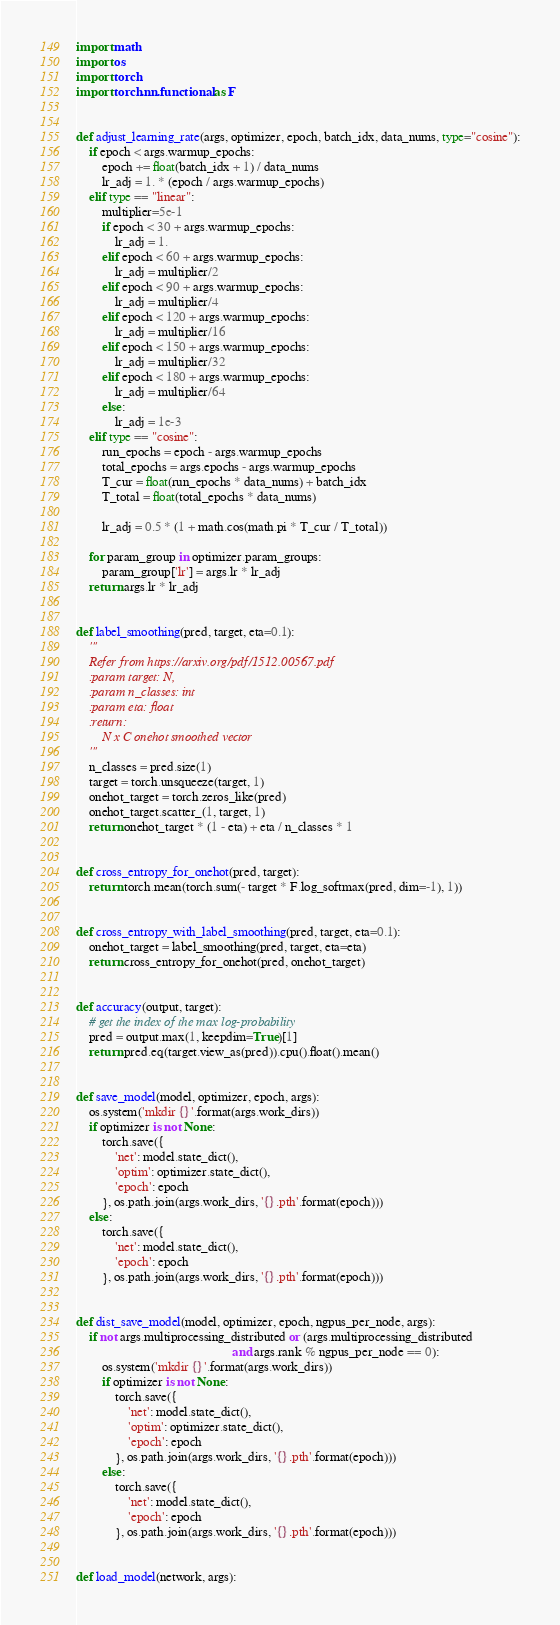Convert code to text. <code><loc_0><loc_0><loc_500><loc_500><_Python_>import math
import os
import torch
import torch.nn.functional as F


def adjust_learning_rate(args, optimizer, epoch, batch_idx, data_nums, type="cosine"):
    if epoch < args.warmup_epochs:
        epoch += float(batch_idx + 1) / data_nums
        lr_adj = 1. * (epoch / args.warmup_epochs)
    elif type == "linear":
        multiplier=5e-1
        if epoch < 30 + args.warmup_epochs:
            lr_adj = 1.
        elif epoch < 60 + args.warmup_epochs:
            lr_adj = multiplier/2
        elif epoch < 90 + args.warmup_epochs:
            lr_adj = multiplier/4
        elif epoch < 120 + args.warmup_epochs:
            lr_adj = multiplier/16
        elif epoch < 150 + args.warmup_epochs:
            lr_adj = multiplier/32
        elif epoch < 180 + args.warmup_epochs:
            lr_adj = multiplier/64
        else:
            lr_adj = 1e-3
    elif type == "cosine":
        run_epochs = epoch - args.warmup_epochs
        total_epochs = args.epochs - args.warmup_epochs
        T_cur = float(run_epochs * data_nums) + batch_idx
        T_total = float(total_epochs * data_nums)

        lr_adj = 0.5 * (1 + math.cos(math.pi * T_cur / T_total))

    for param_group in optimizer.param_groups:
        param_group['lr'] = args.lr * lr_adj
    return args.lr * lr_adj


def label_smoothing(pred, target, eta=0.1):
    '''
    Refer from https://arxiv.org/pdf/1512.00567.pdf
    :param target: N,
    :param n_classes: int
    :param eta: float
    :return:
        N x C onehot smoothed vector
    '''
    n_classes = pred.size(1)
    target = torch.unsqueeze(target, 1)
    onehot_target = torch.zeros_like(pred)
    onehot_target.scatter_(1, target, 1)
    return onehot_target * (1 - eta) + eta / n_classes * 1


def cross_entropy_for_onehot(pred, target):
    return torch.mean(torch.sum(- target * F.log_softmax(pred, dim=-1), 1))


def cross_entropy_with_label_smoothing(pred, target, eta=0.1):
    onehot_target = label_smoothing(pred, target, eta=eta)
    return cross_entropy_for_onehot(pred, onehot_target)


def accuracy(output, target):
    # get the index of the max log-probability
    pred = output.max(1, keepdim=True)[1]
    return pred.eq(target.view_as(pred)).cpu().float().mean()


def save_model(model, optimizer, epoch, args):
    os.system('mkdir {}'.format(args.work_dirs))
    if optimizer is not None:
        torch.save({
            'net': model.state_dict(),
            'optim': optimizer.state_dict(),
            'epoch': epoch
        }, os.path.join(args.work_dirs, '{}.pth'.format(epoch)))
    else:
        torch.save({
            'net': model.state_dict(),
            'epoch': epoch
        }, os.path.join(args.work_dirs, '{}.pth'.format(epoch)))


def dist_save_model(model, optimizer, epoch, ngpus_per_node, args):
    if not args.multiprocessing_distributed or (args.multiprocessing_distributed
                                                and args.rank % ngpus_per_node == 0):
        os.system('mkdir {}'.format(args.work_dirs))
        if optimizer is not None:
            torch.save({
                'net': model.state_dict(),
                'optim': optimizer.state_dict(),
                'epoch': epoch
            }, os.path.join(args.work_dirs, '{}.pth'.format(epoch)))
        else:
            torch.save({
                'net': model.state_dict(),
                'epoch': epoch
            }, os.path.join(args.work_dirs, '{}.pth'.format(epoch)))


def load_model(network, args):</code> 